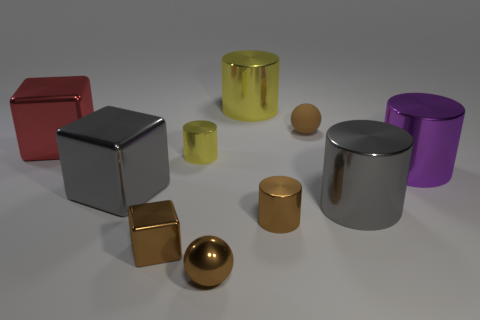Subtract all purple cylinders. How many cylinders are left? 4 Subtract all brown shiny cylinders. How many cylinders are left? 4 Subtract all purple cylinders. Subtract all green cubes. How many cylinders are left? 4 Subtract all blocks. How many objects are left? 7 Subtract all tiny brown shiny balls. Subtract all large gray metal cylinders. How many objects are left? 8 Add 2 small blocks. How many small blocks are left? 3 Add 9 large yellow things. How many large yellow things exist? 10 Subtract 2 brown balls. How many objects are left? 8 